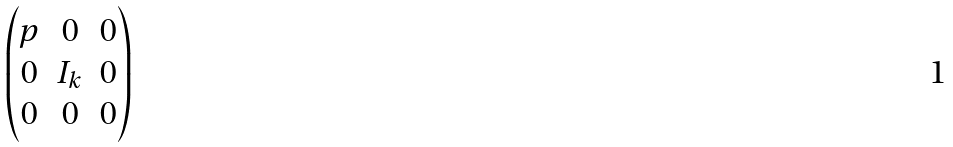<formula> <loc_0><loc_0><loc_500><loc_500>\begin{pmatrix} p & 0 & 0 \\ 0 & I _ { k } & 0 \\ 0 & 0 & 0 \end{pmatrix}</formula> 